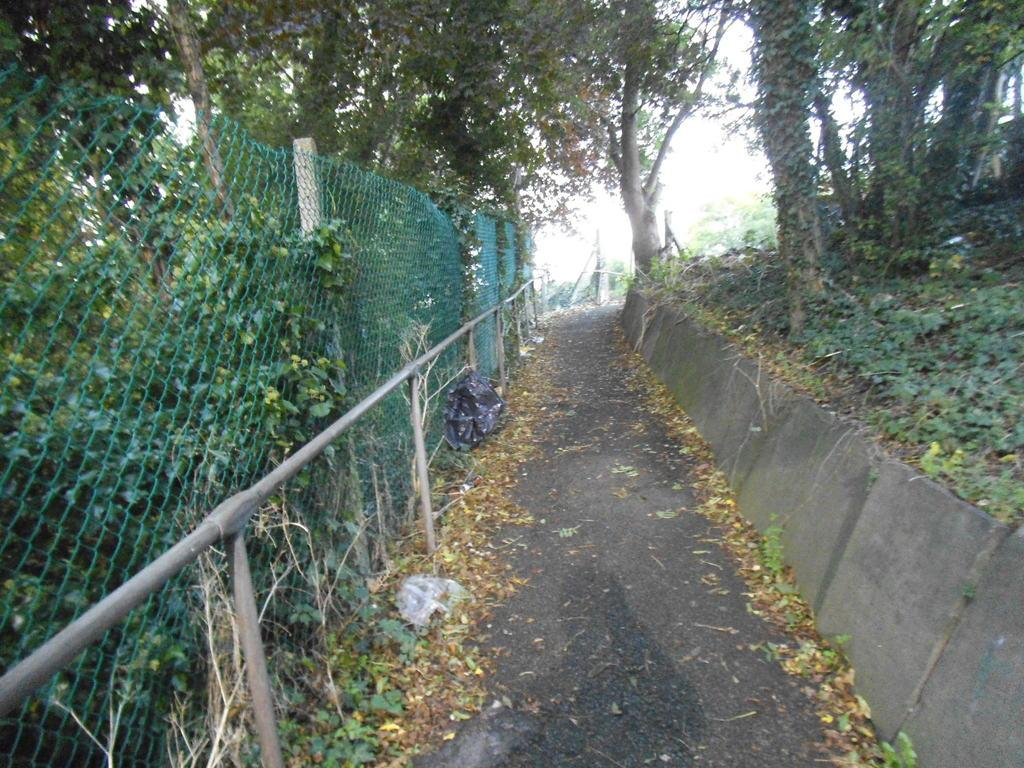What is the main feature in the center of the image? There is a road in the center of the image. What type of vegetation can be seen on both sides of the road? There are trees and grass visible on both sides of the road. Is there any fencing present in the image? Yes, there is fencing on the left side of the image. What type of statement is written on the sweater in the image? There is no sweater present in the image, so it is not possible to answer that question. 